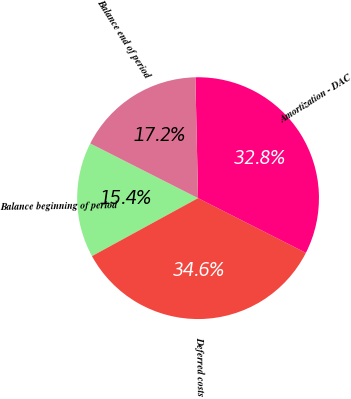<chart> <loc_0><loc_0><loc_500><loc_500><pie_chart><fcel>Balance beginning of period<fcel>Deferred costs<fcel>Amortization - DAC<fcel>Balance end of period<nl><fcel>15.43%<fcel>34.57%<fcel>32.82%<fcel>17.18%<nl></chart> 